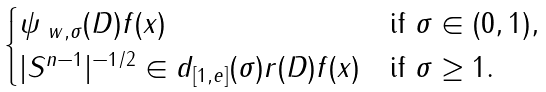Convert formula to latex. <formula><loc_0><loc_0><loc_500><loc_500>\begin{cases} \psi _ { \ w , \sigma } ( D ) f ( x ) & \text {if } \sigma \in ( 0 , 1 ) , \\ | S ^ { n - 1 } | ^ { - 1 / 2 } \in d _ { [ 1 , e ] } ( \sigma ) r ( D ) f ( x ) & \text {if } \sigma \geq 1 . \end{cases}</formula> 